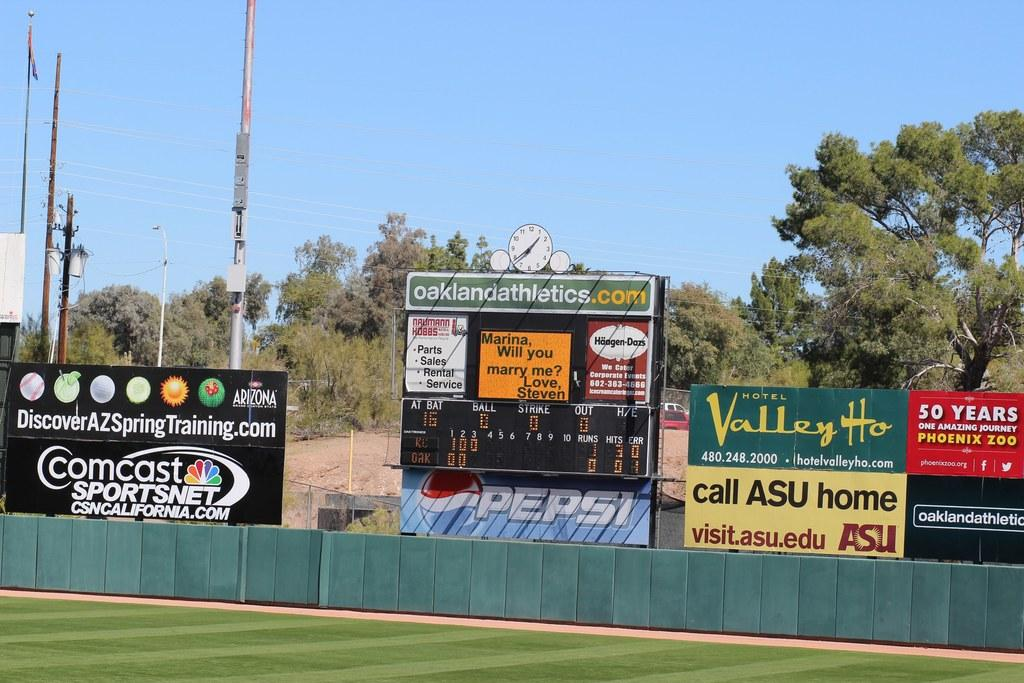<image>
Relay a brief, clear account of the picture shown. A scoreboard with oaklandathletics.com at the top of it. 